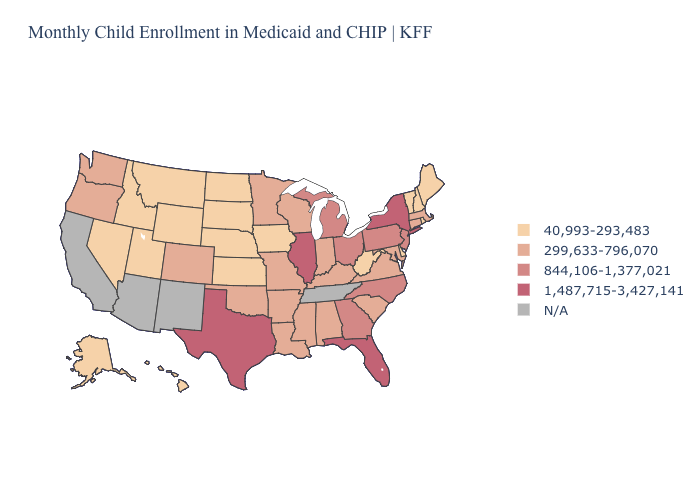Is the legend a continuous bar?
Short answer required. No. Which states have the lowest value in the Northeast?
Quick response, please. Maine, New Hampshire, Rhode Island, Vermont. What is the value of Missouri?
Concise answer only. 299,633-796,070. What is the value of Idaho?
Answer briefly. 40,993-293,483. Among the states that border Colorado , which have the lowest value?
Concise answer only. Kansas, Nebraska, Utah, Wyoming. Which states have the highest value in the USA?
Keep it brief. Florida, Illinois, New York, Texas. Among the states that border Illinois , does Iowa have the lowest value?
Be succinct. Yes. Does Rhode Island have the highest value in the Northeast?
Answer briefly. No. What is the lowest value in the MidWest?
Answer briefly. 40,993-293,483. Name the states that have a value in the range N/A?
Write a very short answer. Arizona, California, New Mexico, Tennessee. What is the lowest value in the USA?
Short answer required. 40,993-293,483. Name the states that have a value in the range 299,633-796,070?
Answer briefly. Alabama, Arkansas, Colorado, Connecticut, Indiana, Kentucky, Louisiana, Maryland, Massachusetts, Minnesota, Mississippi, Missouri, Oklahoma, Oregon, South Carolina, Virginia, Washington, Wisconsin. Name the states that have a value in the range 844,106-1,377,021?
Give a very brief answer. Georgia, Michigan, New Jersey, North Carolina, Ohio, Pennsylvania. Name the states that have a value in the range 40,993-293,483?
Keep it brief. Alaska, Delaware, Hawaii, Idaho, Iowa, Kansas, Maine, Montana, Nebraska, Nevada, New Hampshire, North Dakota, Rhode Island, South Dakota, Utah, Vermont, West Virginia, Wyoming. 